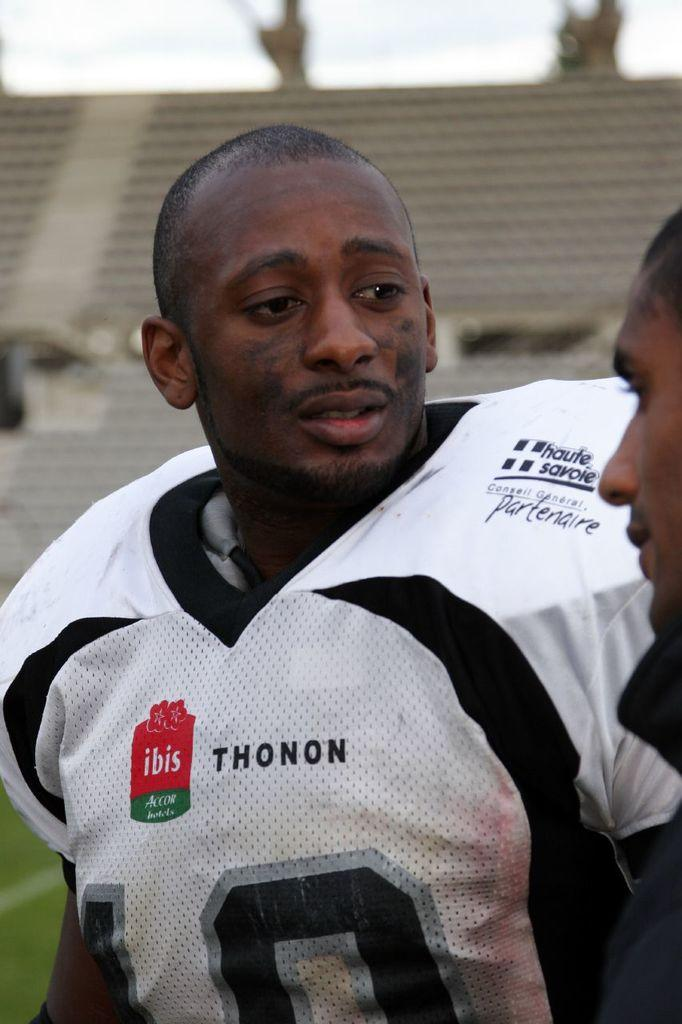<image>
Share a concise interpretation of the image provided. A football player in a white jersey that has advertisements for Thonon and ibis on it. 